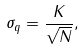<formula> <loc_0><loc_0><loc_500><loc_500>\sigma _ { q } = \frac { K } { \sqrt { N } } ,</formula> 